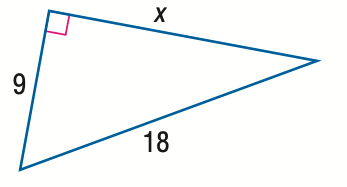Question: Find x.
Choices:
A. 3 \sqrt { 3 }
B. 9
C. 9 \sqrt { 2 }
D. 9 \sqrt { 3 }
Answer with the letter. Answer: D 